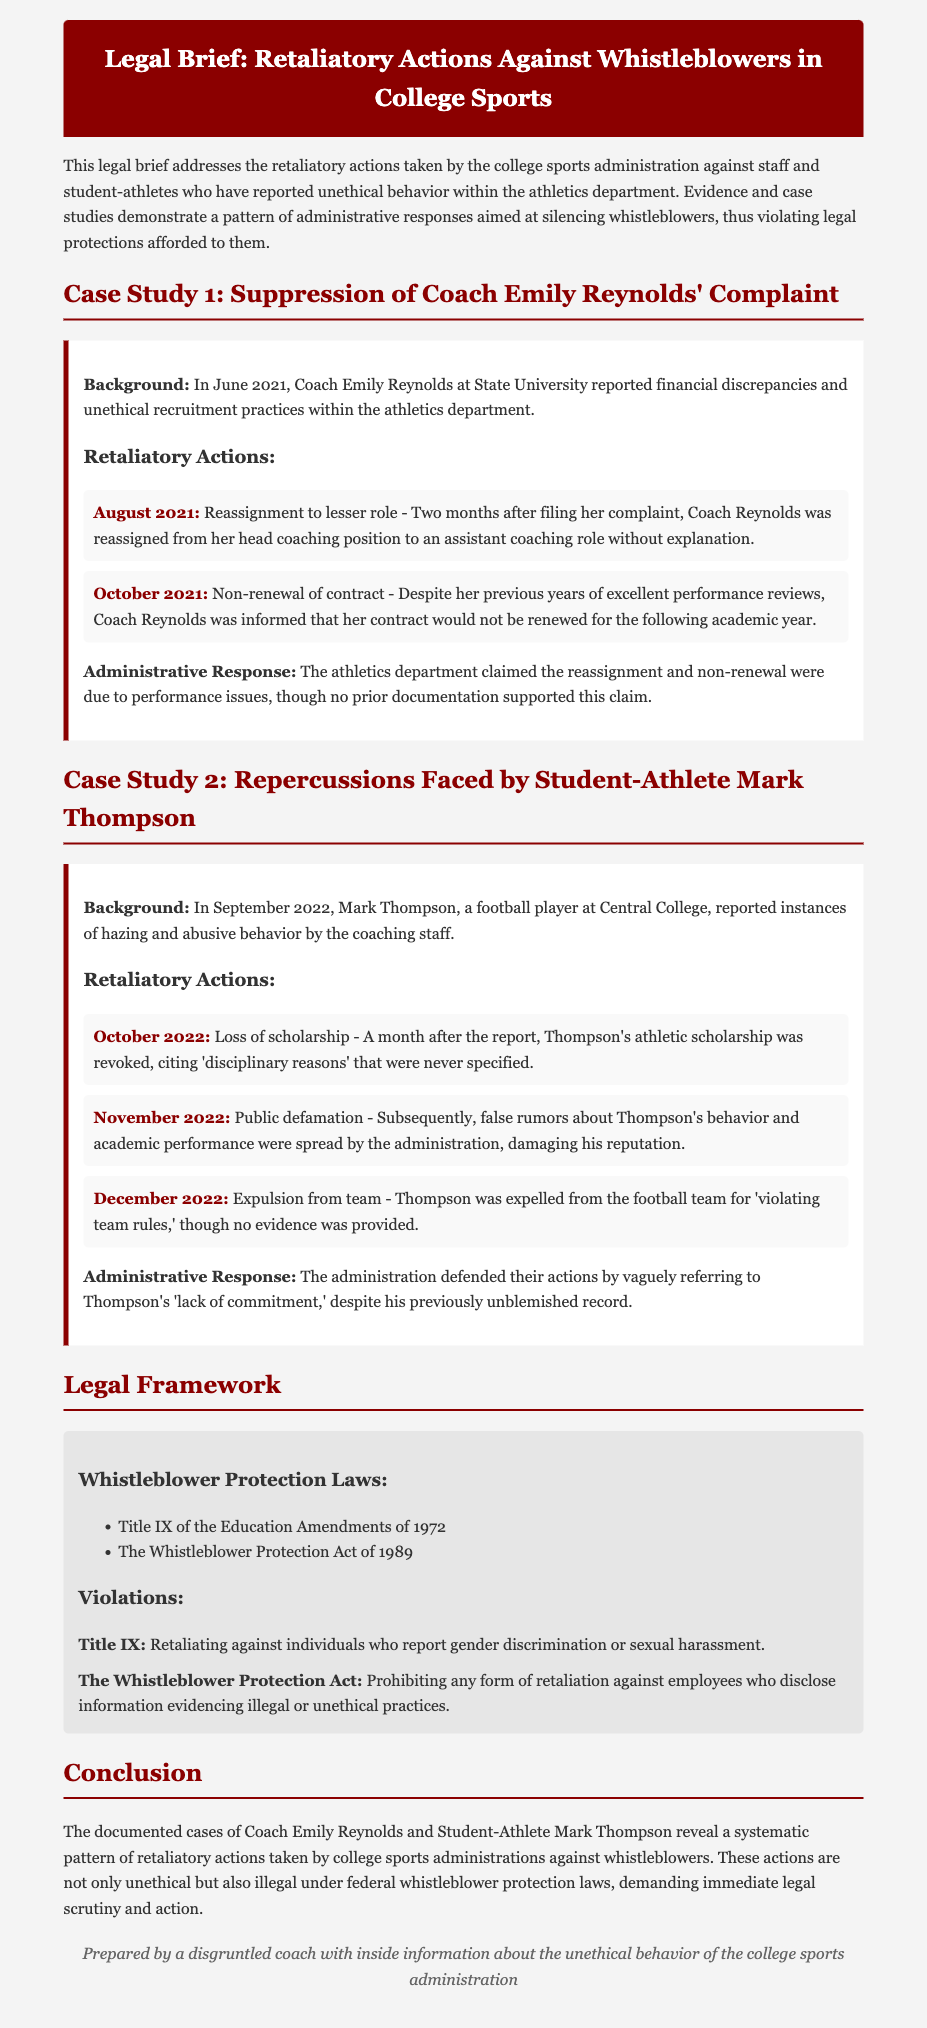What is the title of the legal brief? The title is stated at the top of the document.
Answer: Legal Brief: Retaliatory Actions Against Whistleblowers in College Sports Who is the complainant in Case Study 1? The background of Case Study 1 identifies the complainant.
Answer: Coach Emily Reynolds In which month did Mark Thompson report hazing? The specific month of Thompson's report is mentioned in the case study.
Answer: September 2022 What action was taken against Coach Reynolds in October 2021? The document outlines the actions taken against Coach Reynolds in chronological order.
Answer: Non-renewal of contract What was the reason cited for Thompson losing his scholarship? The document specifies the reason given for the revocation of Thompson's scholarship.
Answer: Disciplinary reasons Which act prohibits retaliation against whistleblowers? The legal framework section mentions the law protecting whistleblowers explicitly.
Answer: The Whistleblower Protection Act of 1989 What was a common administrative response to the complaints? The conclusion summarizes the administrative response patterns in handling complaints.
Answer: Silencing whistleblowers What was the outcome for Thompson in December 2022? The document details the actions taken against Thompson, including the final outcome at that date.
Answer: Expulsion from team 